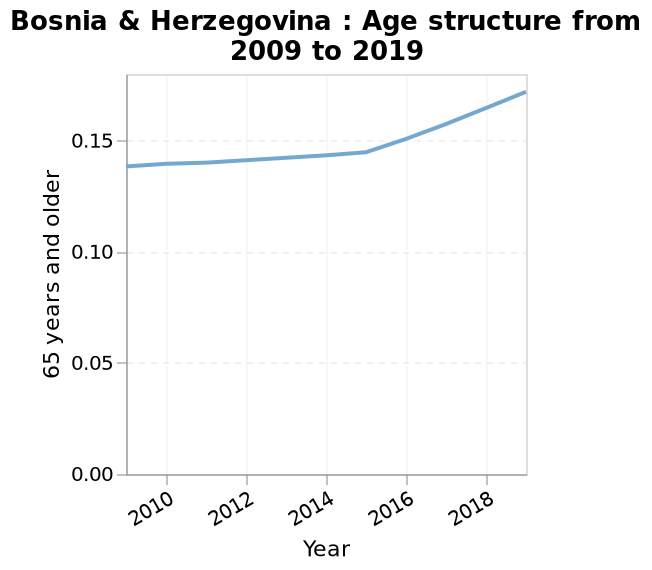<image>
What is the range of the y-axis and what does it represent? The y-axis has a scale from 0.00 to 0.15 and it represents the percentage of the population aged 65 years and older. 